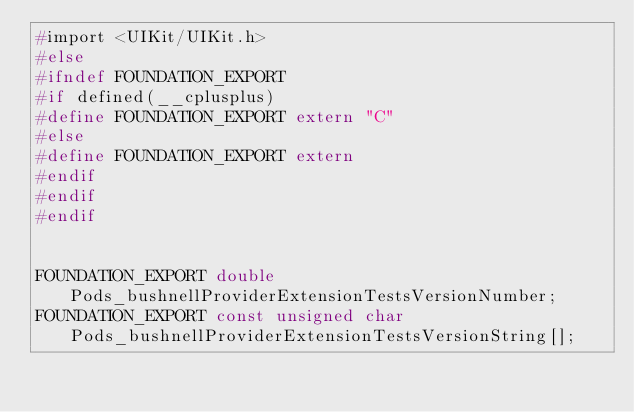Convert code to text. <code><loc_0><loc_0><loc_500><loc_500><_C_>#import <UIKit/UIKit.h>
#else
#ifndef FOUNDATION_EXPORT
#if defined(__cplusplus)
#define FOUNDATION_EXPORT extern "C"
#else
#define FOUNDATION_EXPORT extern
#endif
#endif
#endif


FOUNDATION_EXPORT double Pods_bushnellProviderExtensionTestsVersionNumber;
FOUNDATION_EXPORT const unsigned char Pods_bushnellProviderExtensionTestsVersionString[];

</code> 